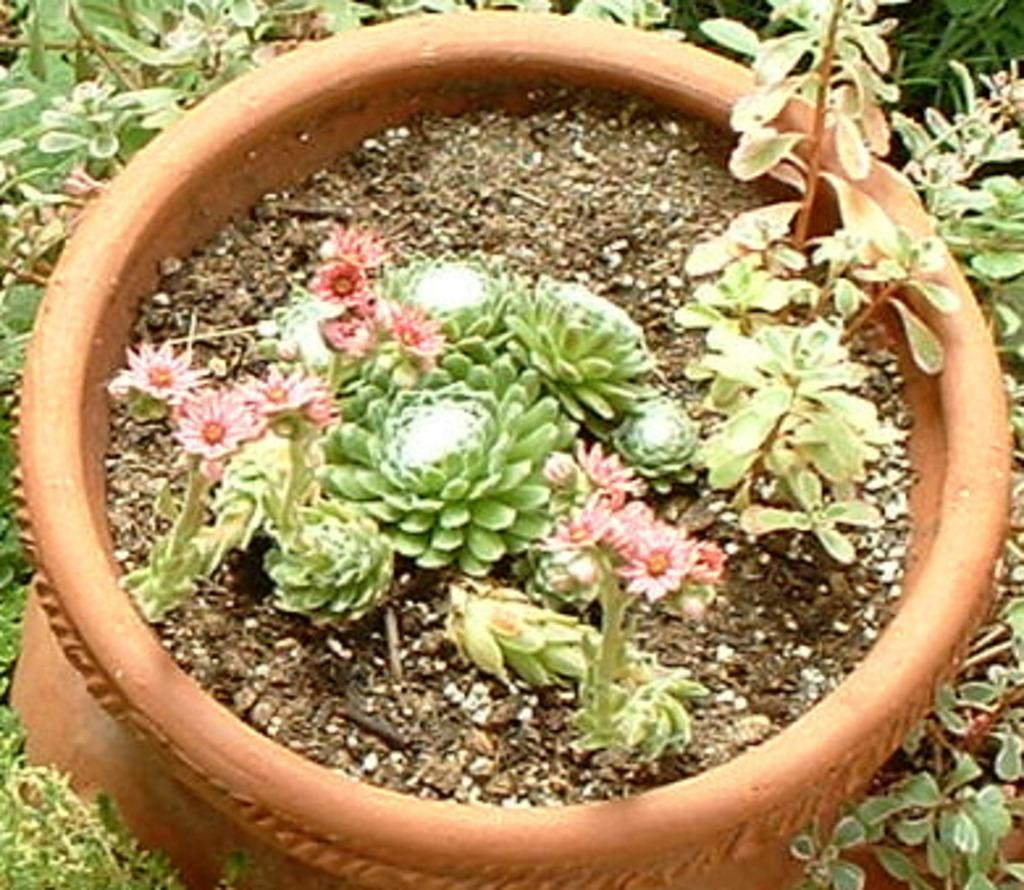What type of plants are in the image? There are plants in a pot in the image. Are there any other plants visible in the image? Yes, there are additional plants on the side of the image. How many pizzas can be seen on the seashore in the image? There are no pizzas or seashore present in the image; it features plants in a pot and additional plants on the side. What type of bird is perched on the plants in the image? There is: There is no bird present in the image; it only features plants in a pot and additional plants on the side. 